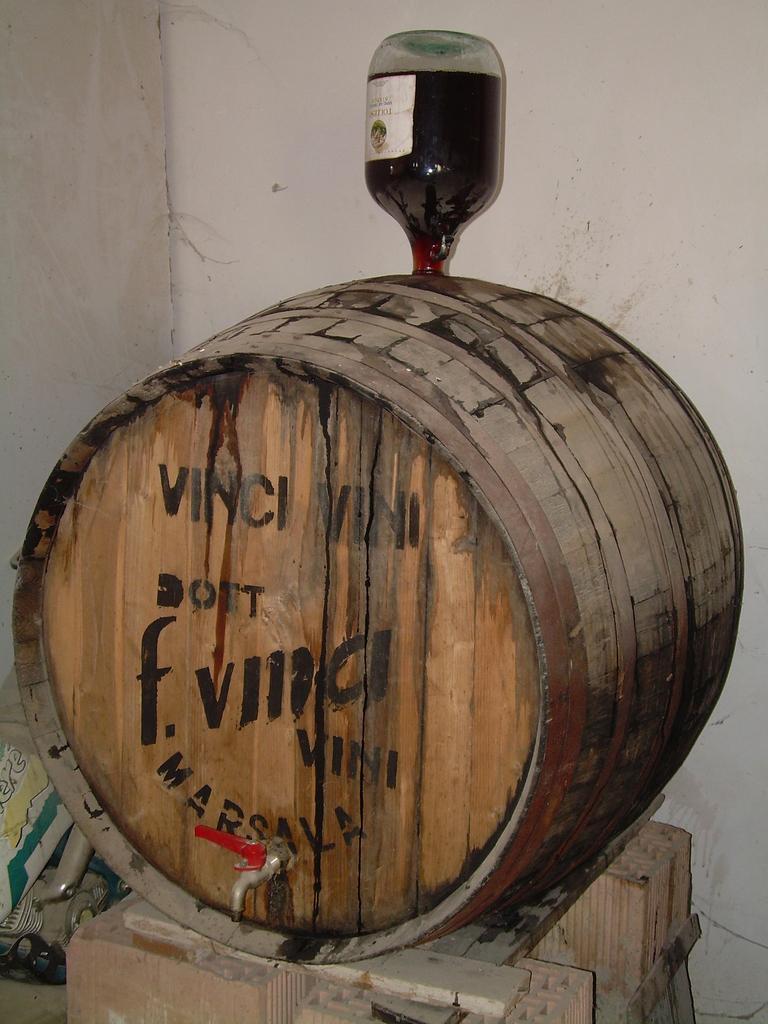In one or two sentences, can you explain what this image depicts? In this picture we can see the wood on the top of that there is a bottle. And this is the wall. 